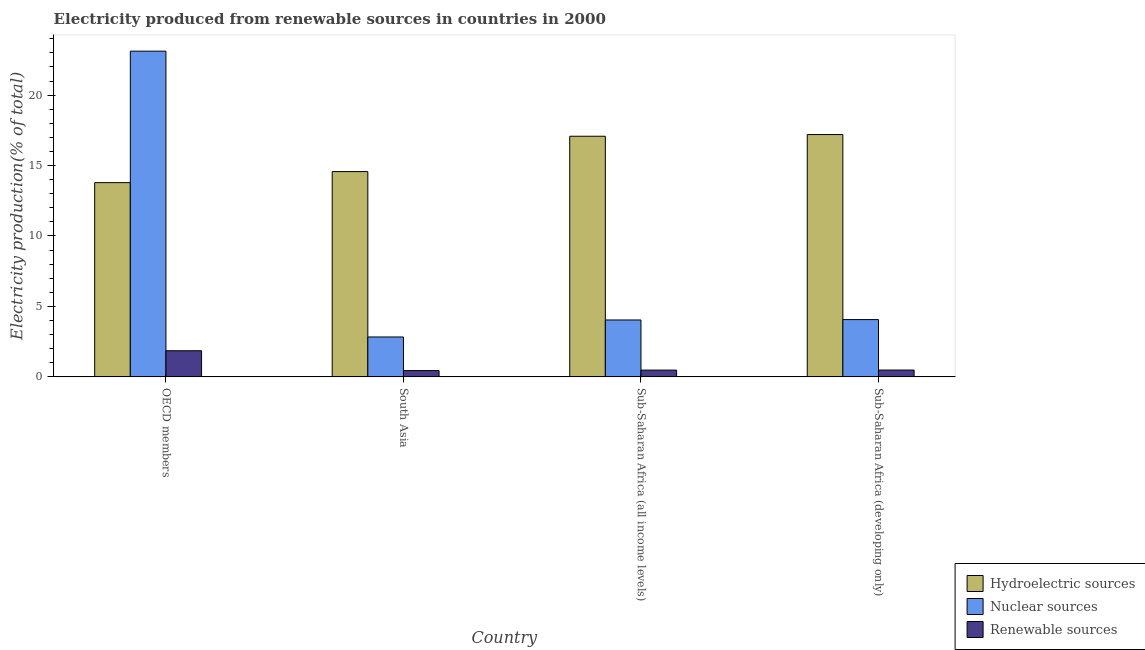How many groups of bars are there?
Your response must be concise. 4. What is the label of the 3rd group of bars from the left?
Provide a succinct answer. Sub-Saharan Africa (all income levels). In how many cases, is the number of bars for a given country not equal to the number of legend labels?
Keep it short and to the point. 0. What is the percentage of electricity produced by renewable sources in South Asia?
Make the answer very short. 0.45. Across all countries, what is the maximum percentage of electricity produced by nuclear sources?
Give a very brief answer. 23.12. Across all countries, what is the minimum percentage of electricity produced by hydroelectric sources?
Provide a succinct answer. 13.79. What is the total percentage of electricity produced by renewable sources in the graph?
Your answer should be compact. 3.27. What is the difference between the percentage of electricity produced by nuclear sources in OECD members and that in Sub-Saharan Africa (developing only)?
Keep it short and to the point. 19.05. What is the difference between the percentage of electricity produced by nuclear sources in Sub-Saharan Africa (all income levels) and the percentage of electricity produced by renewable sources in OECD members?
Give a very brief answer. 2.18. What is the average percentage of electricity produced by nuclear sources per country?
Provide a succinct answer. 8.51. What is the difference between the percentage of electricity produced by renewable sources and percentage of electricity produced by nuclear sources in Sub-Saharan Africa (all income levels)?
Offer a terse response. -3.56. In how many countries, is the percentage of electricity produced by hydroelectric sources greater than 13 %?
Keep it short and to the point. 4. What is the ratio of the percentage of electricity produced by nuclear sources in South Asia to that in Sub-Saharan Africa (all income levels)?
Ensure brevity in your answer.  0.7. Is the percentage of electricity produced by hydroelectric sources in OECD members less than that in Sub-Saharan Africa (all income levels)?
Provide a succinct answer. Yes. Is the difference between the percentage of electricity produced by nuclear sources in OECD members and South Asia greater than the difference between the percentage of electricity produced by hydroelectric sources in OECD members and South Asia?
Provide a short and direct response. Yes. What is the difference between the highest and the second highest percentage of electricity produced by renewable sources?
Ensure brevity in your answer.  1.37. What is the difference between the highest and the lowest percentage of electricity produced by hydroelectric sources?
Your answer should be compact. 3.41. In how many countries, is the percentage of electricity produced by renewable sources greater than the average percentage of electricity produced by renewable sources taken over all countries?
Your answer should be compact. 1. Is the sum of the percentage of electricity produced by hydroelectric sources in South Asia and Sub-Saharan Africa (all income levels) greater than the maximum percentage of electricity produced by nuclear sources across all countries?
Keep it short and to the point. Yes. What does the 1st bar from the left in Sub-Saharan Africa (all income levels) represents?
Your answer should be compact. Hydroelectric sources. What does the 1st bar from the right in Sub-Saharan Africa (all income levels) represents?
Your answer should be very brief. Renewable sources. Is it the case that in every country, the sum of the percentage of electricity produced by hydroelectric sources and percentage of electricity produced by nuclear sources is greater than the percentage of electricity produced by renewable sources?
Offer a terse response. Yes. Does the graph contain any zero values?
Give a very brief answer. No. Where does the legend appear in the graph?
Give a very brief answer. Bottom right. What is the title of the graph?
Your answer should be compact. Electricity produced from renewable sources in countries in 2000. Does "Social insurance" appear as one of the legend labels in the graph?
Give a very brief answer. No. What is the label or title of the Y-axis?
Keep it short and to the point. Electricity production(% of total). What is the Electricity production(% of total) in Hydroelectric sources in OECD members?
Give a very brief answer. 13.79. What is the Electricity production(% of total) of Nuclear sources in OECD members?
Give a very brief answer. 23.12. What is the Electricity production(% of total) in Renewable sources in OECD members?
Provide a succinct answer. 1.86. What is the Electricity production(% of total) of Hydroelectric sources in South Asia?
Your answer should be compact. 14.57. What is the Electricity production(% of total) in Nuclear sources in South Asia?
Your answer should be very brief. 2.83. What is the Electricity production(% of total) of Renewable sources in South Asia?
Offer a very short reply. 0.45. What is the Electricity production(% of total) in Hydroelectric sources in Sub-Saharan Africa (all income levels)?
Make the answer very short. 17.08. What is the Electricity production(% of total) of Nuclear sources in Sub-Saharan Africa (all income levels)?
Provide a succinct answer. 4.04. What is the Electricity production(% of total) of Renewable sources in Sub-Saharan Africa (all income levels)?
Give a very brief answer. 0.48. What is the Electricity production(% of total) of Hydroelectric sources in Sub-Saharan Africa (developing only)?
Provide a short and direct response. 17.2. What is the Electricity production(% of total) in Nuclear sources in Sub-Saharan Africa (developing only)?
Provide a short and direct response. 4.07. What is the Electricity production(% of total) of Renewable sources in Sub-Saharan Africa (developing only)?
Ensure brevity in your answer.  0.48. Across all countries, what is the maximum Electricity production(% of total) of Hydroelectric sources?
Your response must be concise. 17.2. Across all countries, what is the maximum Electricity production(% of total) in Nuclear sources?
Your answer should be very brief. 23.12. Across all countries, what is the maximum Electricity production(% of total) in Renewable sources?
Your answer should be very brief. 1.86. Across all countries, what is the minimum Electricity production(% of total) in Hydroelectric sources?
Ensure brevity in your answer.  13.79. Across all countries, what is the minimum Electricity production(% of total) in Nuclear sources?
Your answer should be compact. 2.83. Across all countries, what is the minimum Electricity production(% of total) of Renewable sources?
Your answer should be very brief. 0.45. What is the total Electricity production(% of total) in Hydroelectric sources in the graph?
Provide a short and direct response. 62.64. What is the total Electricity production(% of total) of Nuclear sources in the graph?
Make the answer very short. 34.06. What is the total Electricity production(% of total) of Renewable sources in the graph?
Offer a terse response. 3.27. What is the difference between the Electricity production(% of total) of Hydroelectric sources in OECD members and that in South Asia?
Your response must be concise. -0.78. What is the difference between the Electricity production(% of total) in Nuclear sources in OECD members and that in South Asia?
Offer a terse response. 20.29. What is the difference between the Electricity production(% of total) of Renewable sources in OECD members and that in South Asia?
Your response must be concise. 1.41. What is the difference between the Electricity production(% of total) in Hydroelectric sources in OECD members and that in Sub-Saharan Africa (all income levels)?
Your answer should be very brief. -3.29. What is the difference between the Electricity production(% of total) of Nuclear sources in OECD members and that in Sub-Saharan Africa (all income levels)?
Your answer should be compact. 19.08. What is the difference between the Electricity production(% of total) in Renewable sources in OECD members and that in Sub-Saharan Africa (all income levels)?
Ensure brevity in your answer.  1.37. What is the difference between the Electricity production(% of total) in Hydroelectric sources in OECD members and that in Sub-Saharan Africa (developing only)?
Provide a short and direct response. -3.41. What is the difference between the Electricity production(% of total) of Nuclear sources in OECD members and that in Sub-Saharan Africa (developing only)?
Make the answer very short. 19.05. What is the difference between the Electricity production(% of total) in Renewable sources in OECD members and that in Sub-Saharan Africa (developing only)?
Your answer should be compact. 1.37. What is the difference between the Electricity production(% of total) of Hydroelectric sources in South Asia and that in Sub-Saharan Africa (all income levels)?
Your response must be concise. -2.51. What is the difference between the Electricity production(% of total) of Nuclear sources in South Asia and that in Sub-Saharan Africa (all income levels)?
Offer a very short reply. -1.21. What is the difference between the Electricity production(% of total) of Renewable sources in South Asia and that in Sub-Saharan Africa (all income levels)?
Your response must be concise. -0.04. What is the difference between the Electricity production(% of total) in Hydroelectric sources in South Asia and that in Sub-Saharan Africa (developing only)?
Your answer should be very brief. -2.63. What is the difference between the Electricity production(% of total) in Nuclear sources in South Asia and that in Sub-Saharan Africa (developing only)?
Make the answer very short. -1.23. What is the difference between the Electricity production(% of total) in Renewable sources in South Asia and that in Sub-Saharan Africa (developing only)?
Your answer should be compact. -0.04. What is the difference between the Electricity production(% of total) of Hydroelectric sources in Sub-Saharan Africa (all income levels) and that in Sub-Saharan Africa (developing only)?
Offer a terse response. -0.12. What is the difference between the Electricity production(% of total) of Nuclear sources in Sub-Saharan Africa (all income levels) and that in Sub-Saharan Africa (developing only)?
Offer a very short reply. -0.03. What is the difference between the Electricity production(% of total) in Renewable sources in Sub-Saharan Africa (all income levels) and that in Sub-Saharan Africa (developing only)?
Keep it short and to the point. -0. What is the difference between the Electricity production(% of total) in Hydroelectric sources in OECD members and the Electricity production(% of total) in Nuclear sources in South Asia?
Ensure brevity in your answer.  10.96. What is the difference between the Electricity production(% of total) in Hydroelectric sources in OECD members and the Electricity production(% of total) in Renewable sources in South Asia?
Ensure brevity in your answer.  13.34. What is the difference between the Electricity production(% of total) of Nuclear sources in OECD members and the Electricity production(% of total) of Renewable sources in South Asia?
Ensure brevity in your answer.  22.67. What is the difference between the Electricity production(% of total) in Hydroelectric sources in OECD members and the Electricity production(% of total) in Nuclear sources in Sub-Saharan Africa (all income levels)?
Provide a succinct answer. 9.75. What is the difference between the Electricity production(% of total) in Hydroelectric sources in OECD members and the Electricity production(% of total) in Renewable sources in Sub-Saharan Africa (all income levels)?
Offer a very short reply. 13.31. What is the difference between the Electricity production(% of total) of Nuclear sources in OECD members and the Electricity production(% of total) of Renewable sources in Sub-Saharan Africa (all income levels)?
Your answer should be very brief. 22.64. What is the difference between the Electricity production(% of total) of Hydroelectric sources in OECD members and the Electricity production(% of total) of Nuclear sources in Sub-Saharan Africa (developing only)?
Make the answer very short. 9.72. What is the difference between the Electricity production(% of total) in Hydroelectric sources in OECD members and the Electricity production(% of total) in Renewable sources in Sub-Saharan Africa (developing only)?
Give a very brief answer. 13.3. What is the difference between the Electricity production(% of total) in Nuclear sources in OECD members and the Electricity production(% of total) in Renewable sources in Sub-Saharan Africa (developing only)?
Keep it short and to the point. 22.64. What is the difference between the Electricity production(% of total) of Hydroelectric sources in South Asia and the Electricity production(% of total) of Nuclear sources in Sub-Saharan Africa (all income levels)?
Your response must be concise. 10.53. What is the difference between the Electricity production(% of total) in Hydroelectric sources in South Asia and the Electricity production(% of total) in Renewable sources in Sub-Saharan Africa (all income levels)?
Offer a very short reply. 14.09. What is the difference between the Electricity production(% of total) in Nuclear sources in South Asia and the Electricity production(% of total) in Renewable sources in Sub-Saharan Africa (all income levels)?
Ensure brevity in your answer.  2.35. What is the difference between the Electricity production(% of total) of Hydroelectric sources in South Asia and the Electricity production(% of total) of Nuclear sources in Sub-Saharan Africa (developing only)?
Your answer should be very brief. 10.5. What is the difference between the Electricity production(% of total) of Hydroelectric sources in South Asia and the Electricity production(% of total) of Renewable sources in Sub-Saharan Africa (developing only)?
Your answer should be compact. 14.09. What is the difference between the Electricity production(% of total) in Nuclear sources in South Asia and the Electricity production(% of total) in Renewable sources in Sub-Saharan Africa (developing only)?
Your answer should be very brief. 2.35. What is the difference between the Electricity production(% of total) in Hydroelectric sources in Sub-Saharan Africa (all income levels) and the Electricity production(% of total) in Nuclear sources in Sub-Saharan Africa (developing only)?
Provide a succinct answer. 13.01. What is the difference between the Electricity production(% of total) in Hydroelectric sources in Sub-Saharan Africa (all income levels) and the Electricity production(% of total) in Renewable sources in Sub-Saharan Africa (developing only)?
Give a very brief answer. 16.6. What is the difference between the Electricity production(% of total) in Nuclear sources in Sub-Saharan Africa (all income levels) and the Electricity production(% of total) in Renewable sources in Sub-Saharan Africa (developing only)?
Ensure brevity in your answer.  3.55. What is the average Electricity production(% of total) in Hydroelectric sources per country?
Make the answer very short. 15.66. What is the average Electricity production(% of total) of Nuclear sources per country?
Offer a terse response. 8.51. What is the average Electricity production(% of total) in Renewable sources per country?
Provide a short and direct response. 0.82. What is the difference between the Electricity production(% of total) of Hydroelectric sources and Electricity production(% of total) of Nuclear sources in OECD members?
Your answer should be compact. -9.33. What is the difference between the Electricity production(% of total) of Hydroelectric sources and Electricity production(% of total) of Renewable sources in OECD members?
Provide a short and direct response. 11.93. What is the difference between the Electricity production(% of total) of Nuclear sources and Electricity production(% of total) of Renewable sources in OECD members?
Make the answer very short. 21.27. What is the difference between the Electricity production(% of total) in Hydroelectric sources and Electricity production(% of total) in Nuclear sources in South Asia?
Your response must be concise. 11.74. What is the difference between the Electricity production(% of total) of Hydroelectric sources and Electricity production(% of total) of Renewable sources in South Asia?
Ensure brevity in your answer.  14.13. What is the difference between the Electricity production(% of total) in Nuclear sources and Electricity production(% of total) in Renewable sources in South Asia?
Ensure brevity in your answer.  2.39. What is the difference between the Electricity production(% of total) in Hydroelectric sources and Electricity production(% of total) in Nuclear sources in Sub-Saharan Africa (all income levels)?
Your answer should be very brief. 13.04. What is the difference between the Electricity production(% of total) of Hydroelectric sources and Electricity production(% of total) of Renewable sources in Sub-Saharan Africa (all income levels)?
Ensure brevity in your answer.  16.6. What is the difference between the Electricity production(% of total) of Nuclear sources and Electricity production(% of total) of Renewable sources in Sub-Saharan Africa (all income levels)?
Your response must be concise. 3.56. What is the difference between the Electricity production(% of total) in Hydroelectric sources and Electricity production(% of total) in Nuclear sources in Sub-Saharan Africa (developing only)?
Make the answer very short. 13.13. What is the difference between the Electricity production(% of total) in Hydroelectric sources and Electricity production(% of total) in Renewable sources in Sub-Saharan Africa (developing only)?
Your response must be concise. 16.72. What is the difference between the Electricity production(% of total) in Nuclear sources and Electricity production(% of total) in Renewable sources in Sub-Saharan Africa (developing only)?
Your answer should be compact. 3.58. What is the ratio of the Electricity production(% of total) in Hydroelectric sources in OECD members to that in South Asia?
Provide a succinct answer. 0.95. What is the ratio of the Electricity production(% of total) in Nuclear sources in OECD members to that in South Asia?
Provide a short and direct response. 8.16. What is the ratio of the Electricity production(% of total) of Renewable sources in OECD members to that in South Asia?
Provide a short and direct response. 4.16. What is the ratio of the Electricity production(% of total) in Hydroelectric sources in OECD members to that in Sub-Saharan Africa (all income levels)?
Make the answer very short. 0.81. What is the ratio of the Electricity production(% of total) in Nuclear sources in OECD members to that in Sub-Saharan Africa (all income levels)?
Your answer should be compact. 5.73. What is the ratio of the Electricity production(% of total) in Renewable sources in OECD members to that in Sub-Saharan Africa (all income levels)?
Provide a succinct answer. 3.86. What is the ratio of the Electricity production(% of total) of Hydroelectric sources in OECD members to that in Sub-Saharan Africa (developing only)?
Provide a short and direct response. 0.8. What is the ratio of the Electricity production(% of total) of Nuclear sources in OECD members to that in Sub-Saharan Africa (developing only)?
Ensure brevity in your answer.  5.69. What is the ratio of the Electricity production(% of total) in Renewable sources in OECD members to that in Sub-Saharan Africa (developing only)?
Ensure brevity in your answer.  3.83. What is the ratio of the Electricity production(% of total) in Hydroelectric sources in South Asia to that in Sub-Saharan Africa (all income levels)?
Keep it short and to the point. 0.85. What is the ratio of the Electricity production(% of total) of Nuclear sources in South Asia to that in Sub-Saharan Africa (all income levels)?
Make the answer very short. 0.7. What is the ratio of the Electricity production(% of total) of Renewable sources in South Asia to that in Sub-Saharan Africa (all income levels)?
Ensure brevity in your answer.  0.93. What is the ratio of the Electricity production(% of total) in Hydroelectric sources in South Asia to that in Sub-Saharan Africa (developing only)?
Keep it short and to the point. 0.85. What is the ratio of the Electricity production(% of total) in Nuclear sources in South Asia to that in Sub-Saharan Africa (developing only)?
Give a very brief answer. 0.7. What is the ratio of the Electricity production(% of total) in Renewable sources in South Asia to that in Sub-Saharan Africa (developing only)?
Your answer should be very brief. 0.92. What is the ratio of the Electricity production(% of total) in Hydroelectric sources in Sub-Saharan Africa (all income levels) to that in Sub-Saharan Africa (developing only)?
Offer a very short reply. 0.99. What is the ratio of the Electricity production(% of total) of Renewable sources in Sub-Saharan Africa (all income levels) to that in Sub-Saharan Africa (developing only)?
Keep it short and to the point. 0.99. What is the difference between the highest and the second highest Electricity production(% of total) of Hydroelectric sources?
Offer a terse response. 0.12. What is the difference between the highest and the second highest Electricity production(% of total) in Nuclear sources?
Your response must be concise. 19.05. What is the difference between the highest and the second highest Electricity production(% of total) in Renewable sources?
Your answer should be compact. 1.37. What is the difference between the highest and the lowest Electricity production(% of total) in Hydroelectric sources?
Make the answer very short. 3.41. What is the difference between the highest and the lowest Electricity production(% of total) in Nuclear sources?
Your answer should be very brief. 20.29. What is the difference between the highest and the lowest Electricity production(% of total) in Renewable sources?
Offer a terse response. 1.41. 